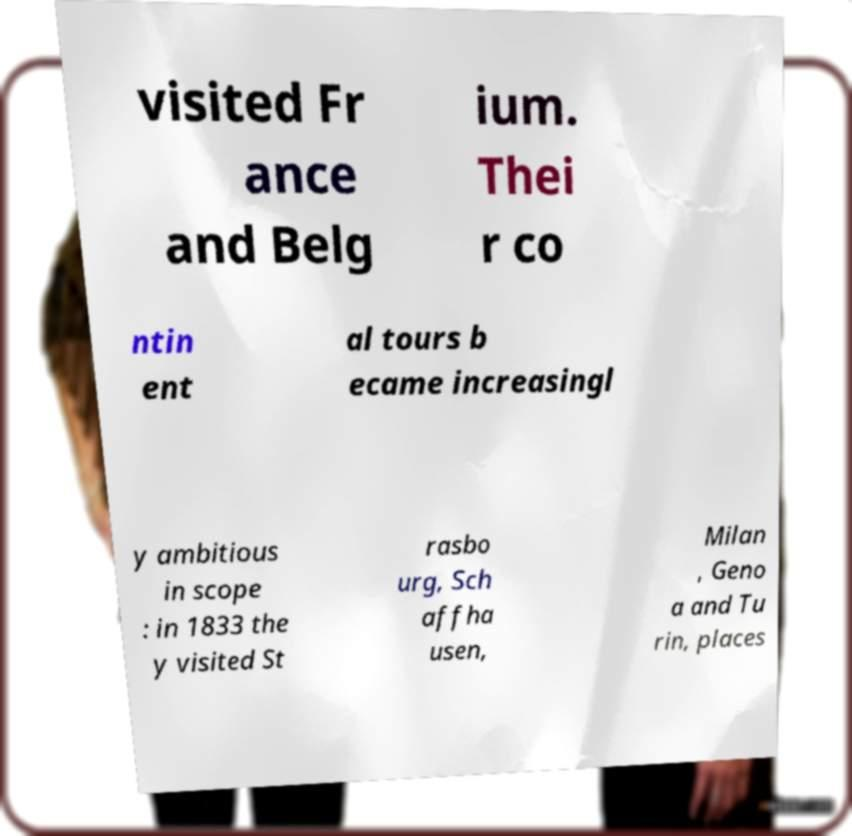Could you assist in decoding the text presented in this image and type it out clearly? visited Fr ance and Belg ium. Thei r co ntin ent al tours b ecame increasingl y ambitious in scope : in 1833 the y visited St rasbo urg, Sch affha usen, Milan , Geno a and Tu rin, places 